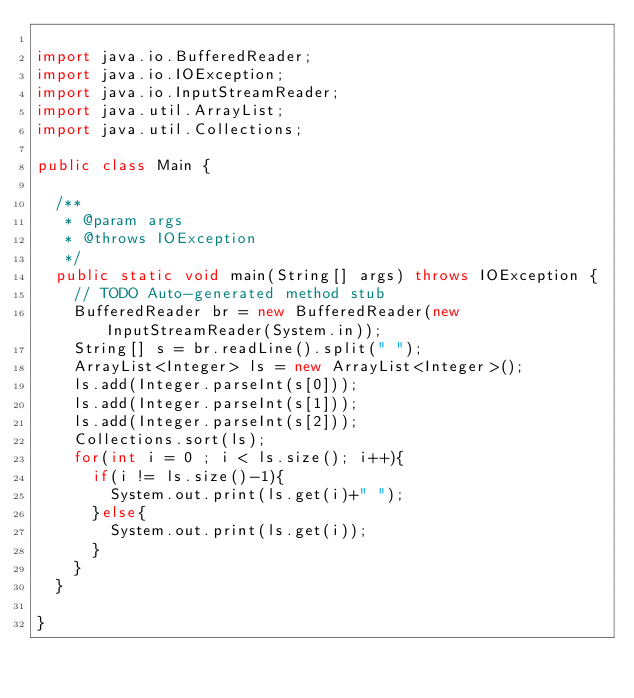Convert code to text. <code><loc_0><loc_0><loc_500><loc_500><_Java_>
import java.io.BufferedReader;
import java.io.IOException;
import java.io.InputStreamReader;
import java.util.ArrayList;
import java.util.Collections;

public class Main {

	/**
	 * @param args
	 * @throws IOException 
	 */
	public static void main(String[] args) throws IOException {
		// TODO Auto-generated method stub
		BufferedReader br = new BufferedReader(new InputStreamReader(System.in));
		String[] s = br.readLine().split(" ");
		ArrayList<Integer> ls = new ArrayList<Integer>();
		ls.add(Integer.parseInt(s[0]));
		ls.add(Integer.parseInt(s[1]));
		ls.add(Integer.parseInt(s[2]));
		Collections.sort(ls);
		for(int i = 0 ; i < ls.size(); i++){
			if(i != ls.size()-1){
				System.out.print(ls.get(i)+" ");
			}else{
				System.out.print(ls.get(i));
			}
		}
	}

}</code> 